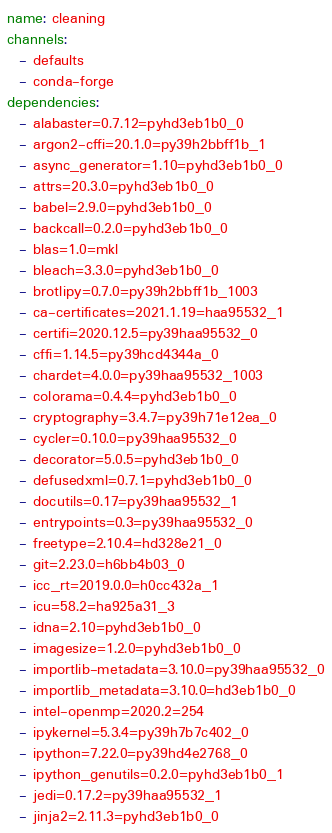<code> <loc_0><loc_0><loc_500><loc_500><_YAML_>name: cleaning
channels:
  - defaults
  - conda-forge
dependencies:
  - alabaster=0.7.12=pyhd3eb1b0_0
  - argon2-cffi=20.1.0=py39h2bbff1b_1
  - async_generator=1.10=pyhd3eb1b0_0
  - attrs=20.3.0=pyhd3eb1b0_0
  - babel=2.9.0=pyhd3eb1b0_0
  - backcall=0.2.0=pyhd3eb1b0_0
  - blas=1.0=mkl
  - bleach=3.3.0=pyhd3eb1b0_0
  - brotlipy=0.7.0=py39h2bbff1b_1003
  - ca-certificates=2021.1.19=haa95532_1
  - certifi=2020.12.5=py39haa95532_0
  - cffi=1.14.5=py39hcd4344a_0
  - chardet=4.0.0=py39haa95532_1003
  - colorama=0.4.4=pyhd3eb1b0_0
  - cryptography=3.4.7=py39h71e12ea_0
  - cycler=0.10.0=py39haa95532_0
  - decorator=5.0.5=pyhd3eb1b0_0
  - defusedxml=0.7.1=pyhd3eb1b0_0
  - docutils=0.17=py39haa95532_1
  - entrypoints=0.3=py39haa95532_0
  - freetype=2.10.4=hd328e21_0
  - git=2.23.0=h6bb4b03_0
  - icc_rt=2019.0.0=h0cc432a_1
  - icu=58.2=ha925a31_3
  - idna=2.10=pyhd3eb1b0_0
  - imagesize=1.2.0=pyhd3eb1b0_0
  - importlib-metadata=3.10.0=py39haa95532_0
  - importlib_metadata=3.10.0=hd3eb1b0_0
  - intel-openmp=2020.2=254
  - ipykernel=5.3.4=py39h7b7c402_0
  - ipython=7.22.0=py39hd4e2768_0
  - ipython_genutils=0.2.0=pyhd3eb1b0_1
  - jedi=0.17.2=py39haa95532_1
  - jinja2=2.11.3=pyhd3eb1b0_0</code> 